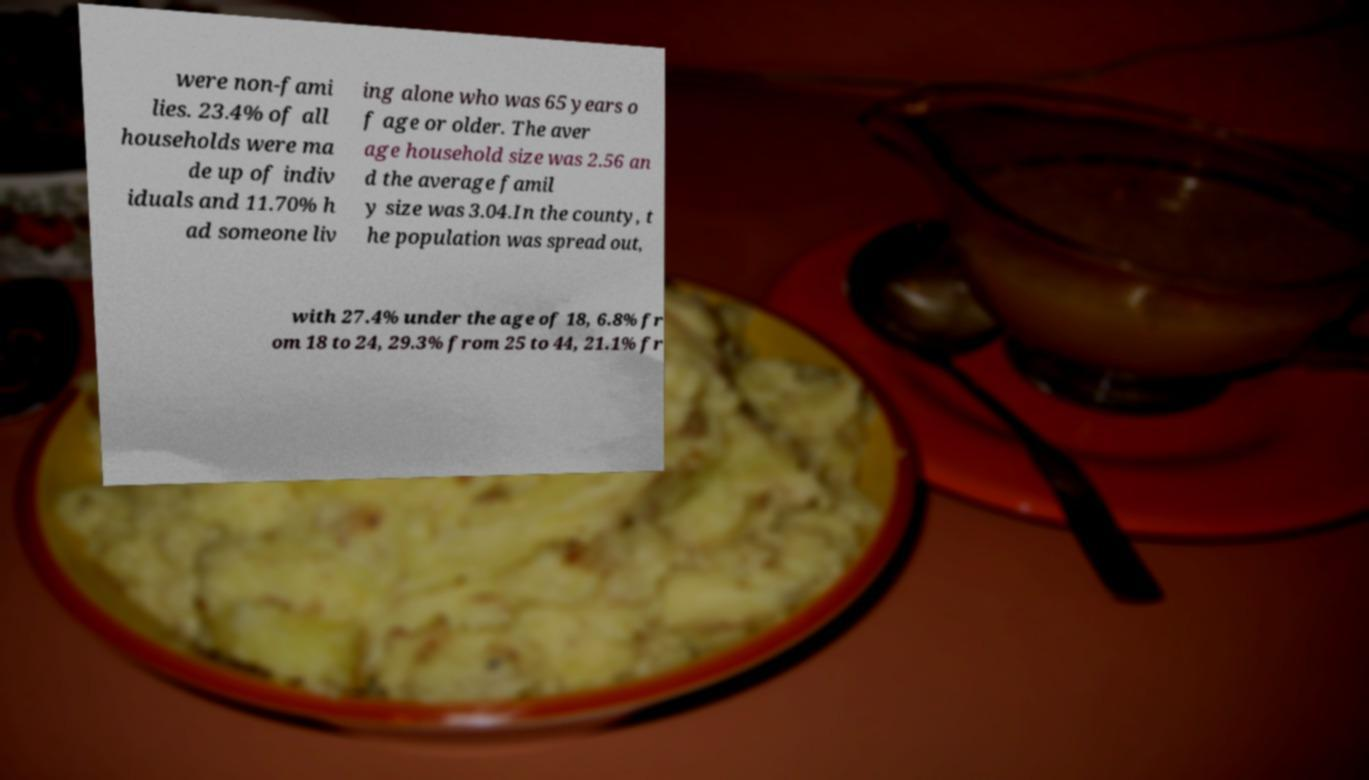Can you accurately transcribe the text from the provided image for me? were non-fami lies. 23.4% of all households were ma de up of indiv iduals and 11.70% h ad someone liv ing alone who was 65 years o f age or older. The aver age household size was 2.56 an d the average famil y size was 3.04.In the county, t he population was spread out, with 27.4% under the age of 18, 6.8% fr om 18 to 24, 29.3% from 25 to 44, 21.1% fr 